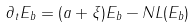Convert formula to latex. <formula><loc_0><loc_0><loc_500><loc_500>\partial _ { t } E _ { b } = ( a + \xi ) E _ { b } - N L ( E _ { b } )</formula> 